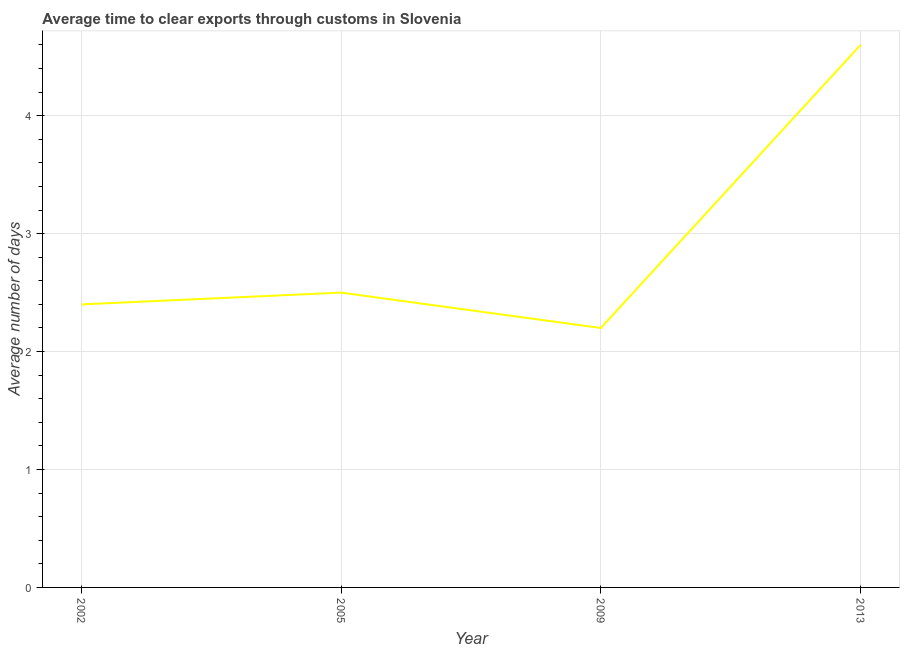What is the time to clear exports through customs in 2005?
Offer a very short reply. 2.5. Across all years, what is the maximum time to clear exports through customs?
Offer a terse response. 4.6. Across all years, what is the minimum time to clear exports through customs?
Provide a succinct answer. 2.2. In which year was the time to clear exports through customs minimum?
Give a very brief answer. 2009. What is the sum of the time to clear exports through customs?
Offer a very short reply. 11.7. What is the difference between the time to clear exports through customs in 2009 and 2013?
Offer a very short reply. -2.4. What is the average time to clear exports through customs per year?
Give a very brief answer. 2.92. What is the median time to clear exports through customs?
Your answer should be compact. 2.45. What is the ratio of the time to clear exports through customs in 2002 to that in 2005?
Your response must be concise. 0.96. What is the difference between the highest and the second highest time to clear exports through customs?
Offer a very short reply. 2.1. What is the difference between the highest and the lowest time to clear exports through customs?
Your answer should be very brief. 2.4. How many lines are there?
Keep it short and to the point. 1. How many years are there in the graph?
Provide a short and direct response. 4. What is the difference between two consecutive major ticks on the Y-axis?
Offer a very short reply. 1. What is the title of the graph?
Ensure brevity in your answer.  Average time to clear exports through customs in Slovenia. What is the label or title of the Y-axis?
Your answer should be compact. Average number of days. What is the Average number of days of 2005?
Your response must be concise. 2.5. What is the Average number of days in 2009?
Provide a succinct answer. 2.2. What is the Average number of days of 2013?
Offer a terse response. 4.6. What is the difference between the Average number of days in 2002 and 2009?
Make the answer very short. 0.2. What is the difference between the Average number of days in 2002 and 2013?
Your answer should be very brief. -2.2. What is the difference between the Average number of days in 2005 and 2009?
Provide a succinct answer. 0.3. What is the ratio of the Average number of days in 2002 to that in 2005?
Your answer should be compact. 0.96. What is the ratio of the Average number of days in 2002 to that in 2009?
Your answer should be compact. 1.09. What is the ratio of the Average number of days in 2002 to that in 2013?
Your answer should be very brief. 0.52. What is the ratio of the Average number of days in 2005 to that in 2009?
Keep it short and to the point. 1.14. What is the ratio of the Average number of days in 2005 to that in 2013?
Your answer should be compact. 0.54. What is the ratio of the Average number of days in 2009 to that in 2013?
Ensure brevity in your answer.  0.48. 